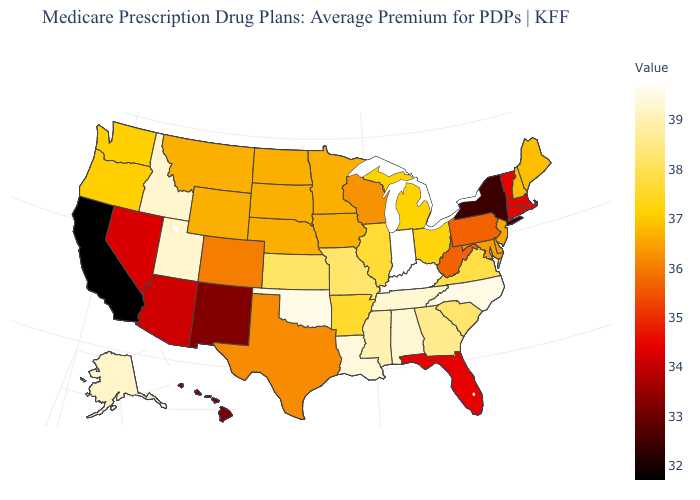Among the states that border Mississippi , does Louisiana have the lowest value?
Be succinct. No. Does the map have missing data?
Write a very short answer. No. Which states have the highest value in the USA?
Write a very short answer. Indiana, Kentucky. Among the states that border Kansas , does Colorado have the highest value?
Keep it brief. No. Which states have the lowest value in the USA?
Write a very short answer. California. 